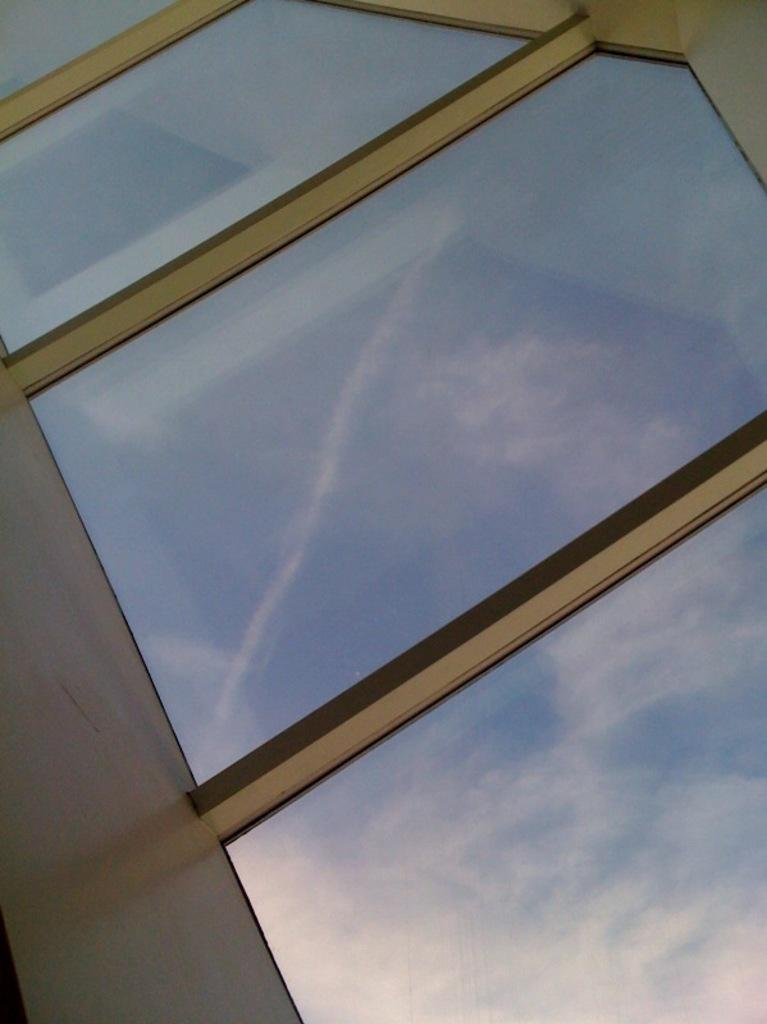What type of material is used for the windows in the image? The windows in the image are made of glass. What can be seen through the windows in the image? The sky is visible through the windows in the image. What is the color of the sky in the image? The sky is blue in color. Are there any clouds in the sky in the image? Yes, the sky is cloudy in the image. Can you see a yam growing on the windowsill in the image? There is no yam visible in the image, as it only features glass windows and a cloudy blue sky. 